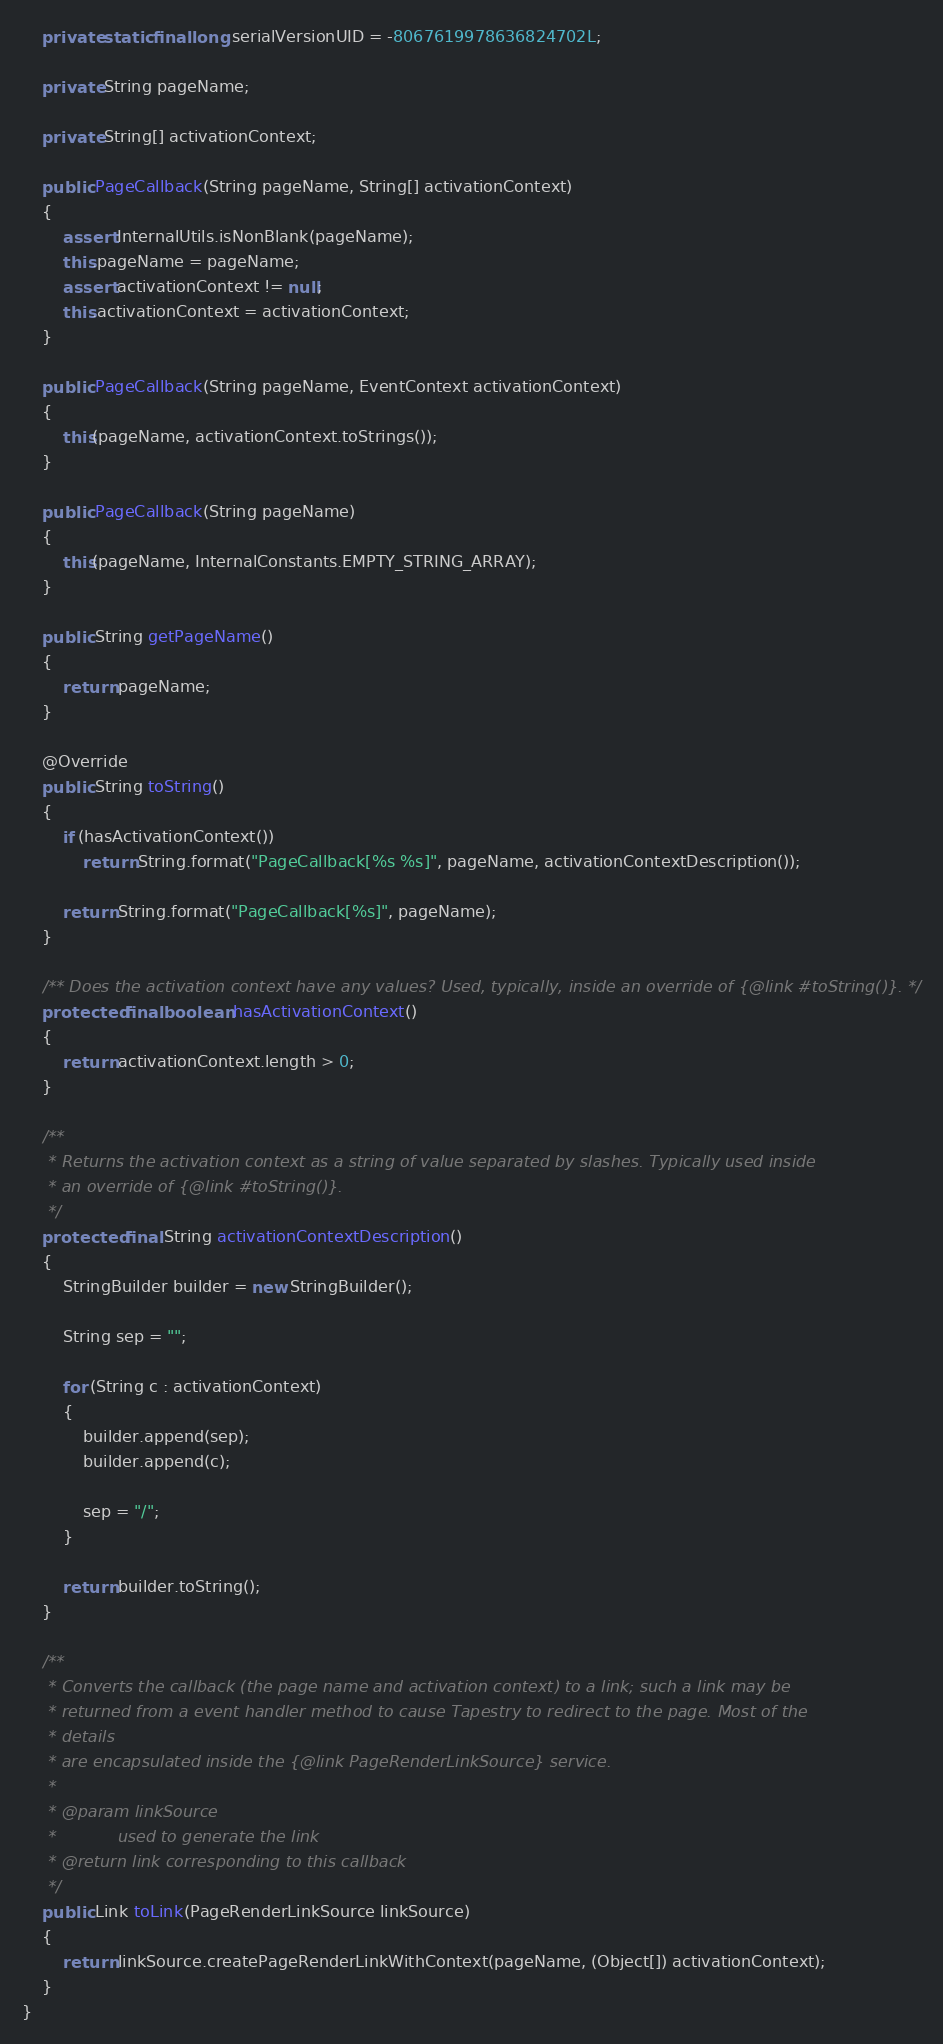<code> <loc_0><loc_0><loc_500><loc_500><_Java_>    private static final long serialVersionUID = -8067619978636824702L;

    private String pageName;

    private String[] activationContext;

    public PageCallback(String pageName, String[] activationContext)
    {
        assert InternalUtils.isNonBlank(pageName);
        this.pageName = pageName;
        assert activationContext != null;
        this.activationContext = activationContext;
    }

    public PageCallback(String pageName, EventContext activationContext)
    {
        this(pageName, activationContext.toStrings());
    }

    public PageCallback(String pageName)
    {
        this(pageName, InternalConstants.EMPTY_STRING_ARRAY);
    }

    public String getPageName()
    {
        return pageName;
    }

    @Override
    public String toString()
    {
        if (hasActivationContext())
            return String.format("PageCallback[%s %s]", pageName, activationContextDescription());

        return String.format("PageCallback[%s]", pageName);
    }

    /** Does the activation context have any values? Used, typically, inside an override of {@link #toString()}. */
    protected final boolean hasActivationContext()
    {
        return activationContext.length > 0;
    }

    /**
     * Returns the activation context as a string of value separated by slashes. Typically used inside
     * an override of {@link #toString()}.
     */
    protected final String activationContextDescription()
    {
        StringBuilder builder = new StringBuilder();

        String sep = "";

        for (String c : activationContext)
        {
            builder.append(sep);
            builder.append(c);

            sep = "/";
        }

        return builder.toString();
    }

    /**
     * Converts the callback (the page name and activation context) to a link; such a link may be
     * returned from a event handler method to cause Tapestry to redirect to the page. Most of the
     * details
     * are encapsulated inside the {@link PageRenderLinkSource} service.
     * 
     * @param linkSource
     *            used to generate the link
     * @return link corresponding to this callback
     */
    public Link toLink(PageRenderLinkSource linkSource)
    {
        return linkSource.createPageRenderLinkWithContext(pageName, (Object[]) activationContext);
    }
}
</code> 